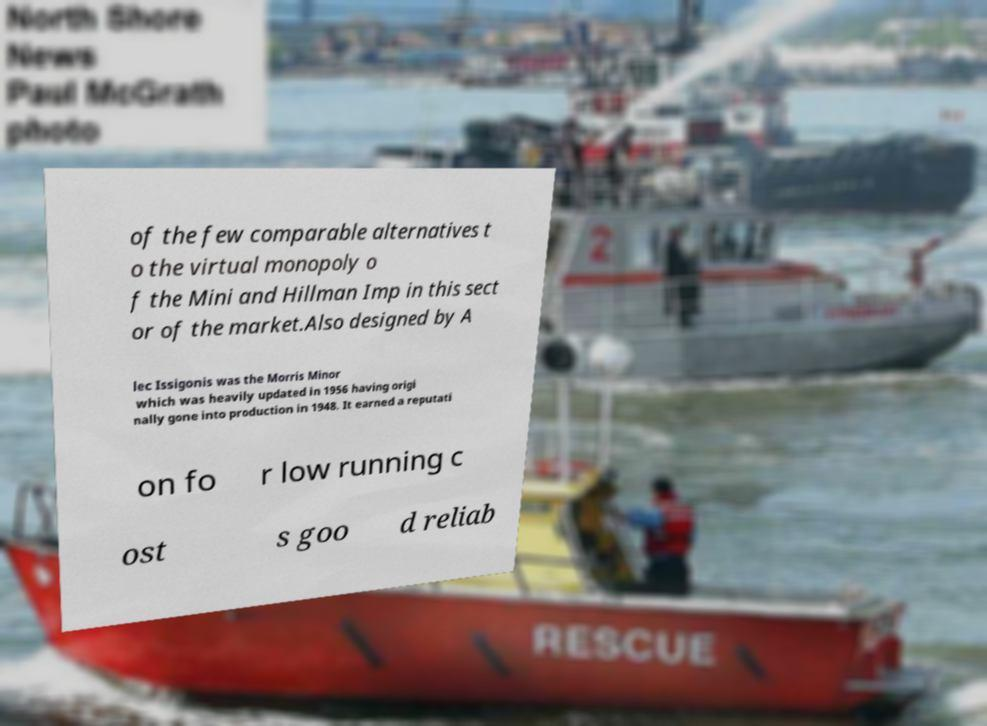Can you read and provide the text displayed in the image?This photo seems to have some interesting text. Can you extract and type it out for me? of the few comparable alternatives t o the virtual monopoly o f the Mini and Hillman Imp in this sect or of the market.Also designed by A lec Issigonis was the Morris Minor which was heavily updated in 1956 having origi nally gone into production in 1948. It earned a reputati on fo r low running c ost s goo d reliab 